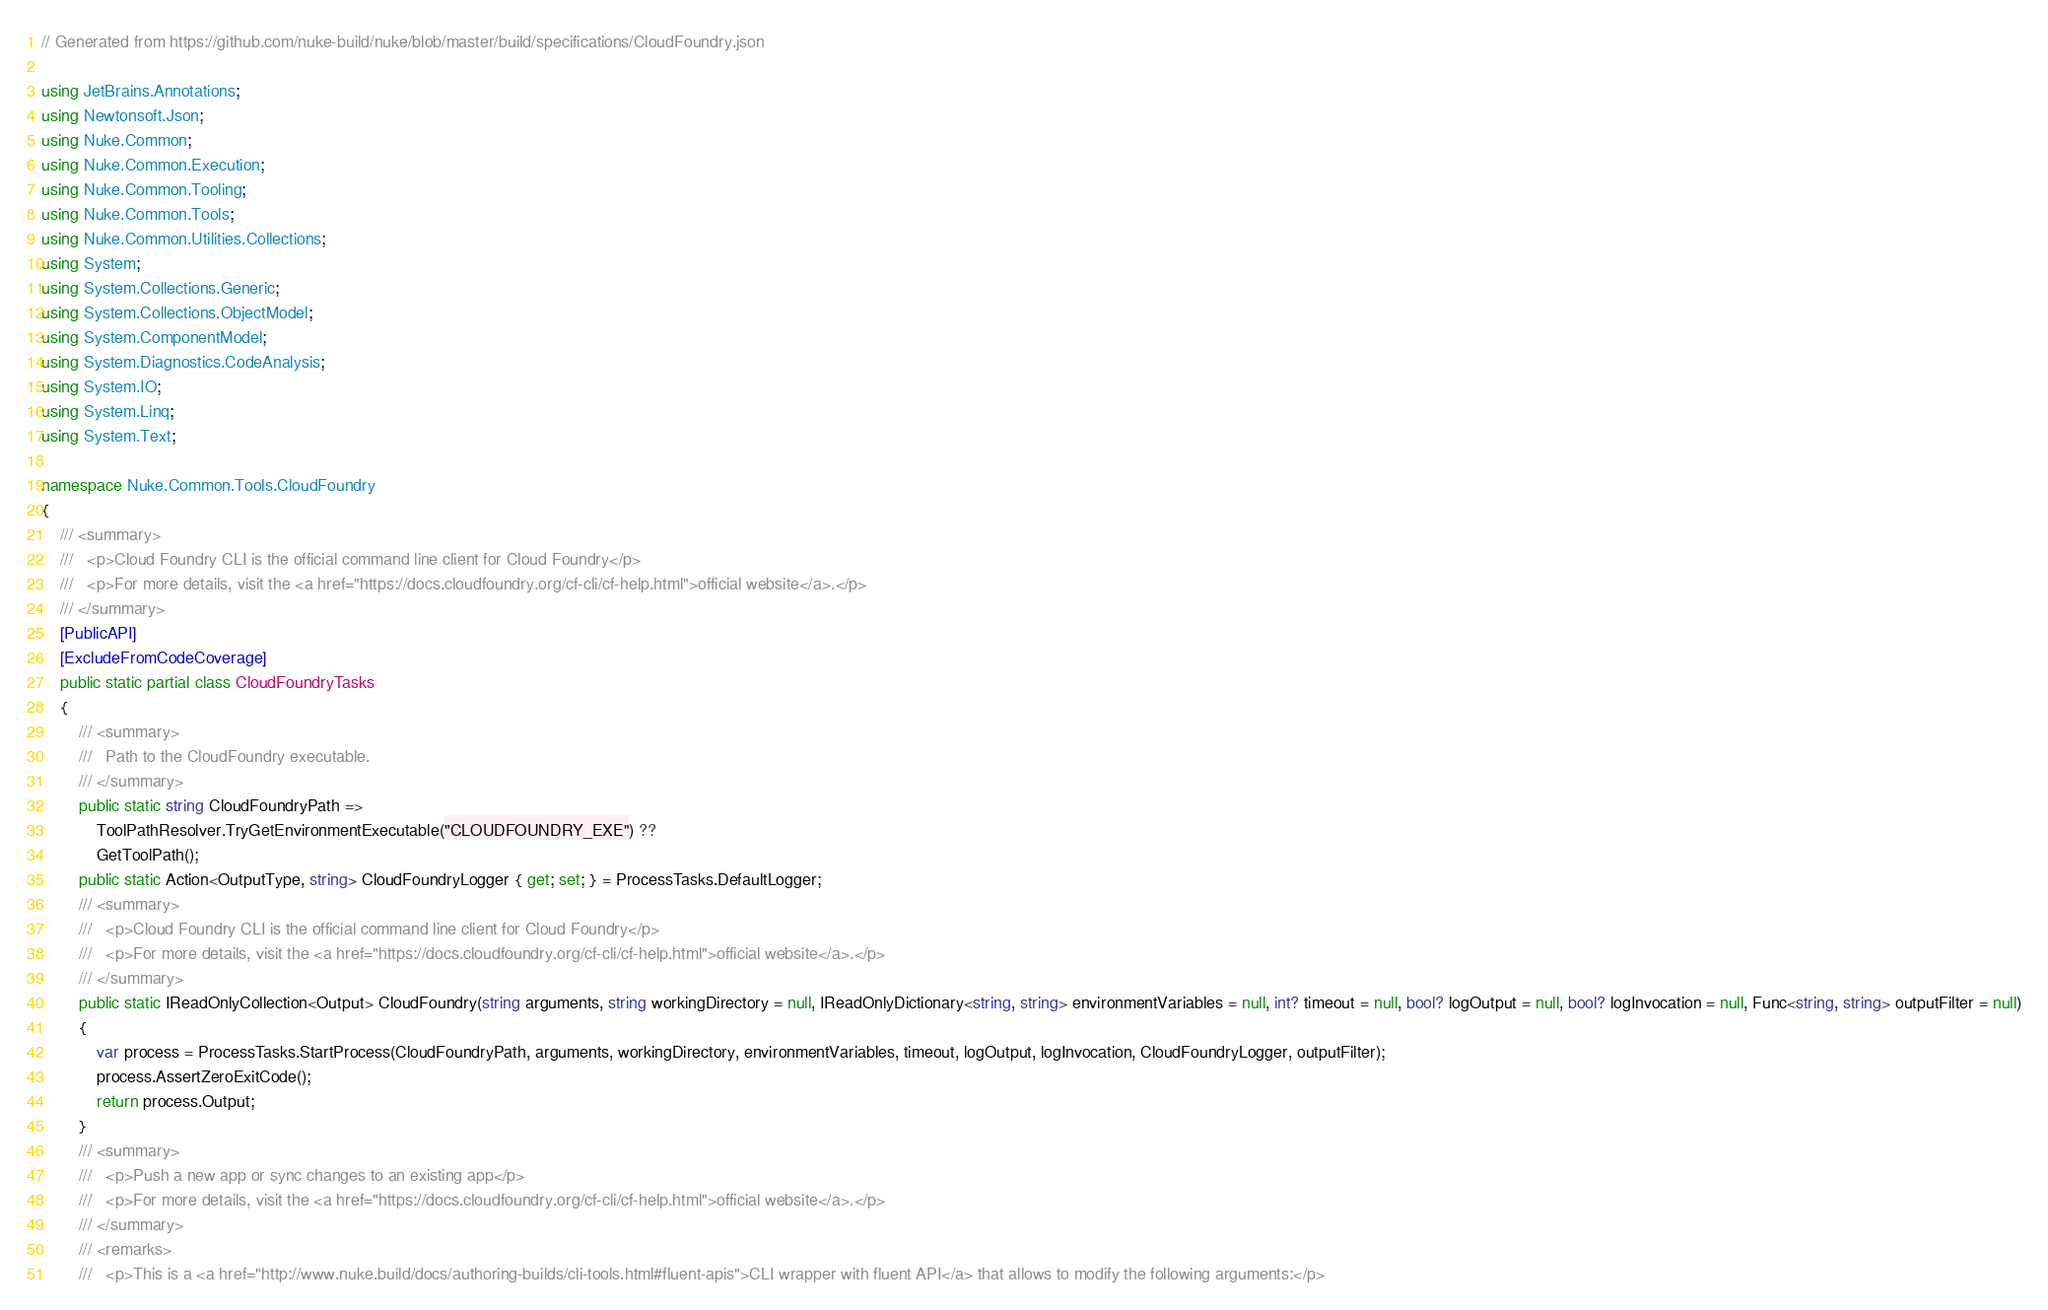Convert code to text. <code><loc_0><loc_0><loc_500><loc_500><_C#_>// Generated from https://github.com/nuke-build/nuke/blob/master/build/specifications/CloudFoundry.json

using JetBrains.Annotations;
using Newtonsoft.Json;
using Nuke.Common;
using Nuke.Common.Execution;
using Nuke.Common.Tooling;
using Nuke.Common.Tools;
using Nuke.Common.Utilities.Collections;
using System;
using System.Collections.Generic;
using System.Collections.ObjectModel;
using System.ComponentModel;
using System.Diagnostics.CodeAnalysis;
using System.IO;
using System.Linq;
using System.Text;

namespace Nuke.Common.Tools.CloudFoundry
{
    /// <summary>
    ///   <p>Cloud Foundry CLI is the official command line client for Cloud Foundry</p>
    ///   <p>For more details, visit the <a href="https://docs.cloudfoundry.org/cf-cli/cf-help.html">official website</a>.</p>
    /// </summary>
    [PublicAPI]
    [ExcludeFromCodeCoverage]
    public static partial class CloudFoundryTasks
    {
        /// <summary>
        ///   Path to the CloudFoundry executable.
        /// </summary>
        public static string CloudFoundryPath =>
            ToolPathResolver.TryGetEnvironmentExecutable("CLOUDFOUNDRY_EXE") ??
            GetToolPath();
        public static Action<OutputType, string> CloudFoundryLogger { get; set; } = ProcessTasks.DefaultLogger;
        /// <summary>
        ///   <p>Cloud Foundry CLI is the official command line client for Cloud Foundry</p>
        ///   <p>For more details, visit the <a href="https://docs.cloudfoundry.org/cf-cli/cf-help.html">official website</a>.</p>
        /// </summary>
        public static IReadOnlyCollection<Output> CloudFoundry(string arguments, string workingDirectory = null, IReadOnlyDictionary<string, string> environmentVariables = null, int? timeout = null, bool? logOutput = null, bool? logInvocation = null, Func<string, string> outputFilter = null)
        {
            var process = ProcessTasks.StartProcess(CloudFoundryPath, arguments, workingDirectory, environmentVariables, timeout, logOutput, logInvocation, CloudFoundryLogger, outputFilter);
            process.AssertZeroExitCode();
            return process.Output;
        }
        /// <summary>
        ///   <p>Push a new app or sync changes to an existing app</p>
        ///   <p>For more details, visit the <a href="https://docs.cloudfoundry.org/cf-cli/cf-help.html">official website</a>.</p>
        /// </summary>
        /// <remarks>
        ///   <p>This is a <a href="http://www.nuke.build/docs/authoring-builds/cli-tools.html#fluent-apis">CLI wrapper with fluent API</a> that allows to modify the following arguments:</p></code> 